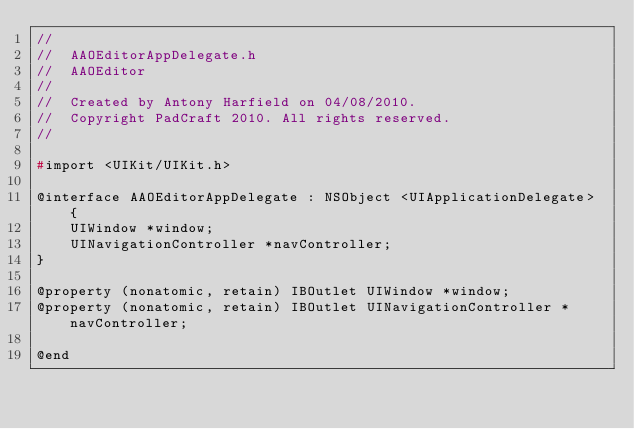Convert code to text. <code><loc_0><loc_0><loc_500><loc_500><_C_>//
//  AAOEditorAppDelegate.h
//  AAOEditor
//
//  Created by Antony Harfield on 04/08/2010.
//  Copyright PadCraft 2010. All rights reserved.
//

#import <UIKit/UIKit.h>

@interface AAOEditorAppDelegate : NSObject <UIApplicationDelegate> {
    UIWindow *window;
	UINavigationController *navController;
}

@property (nonatomic, retain) IBOutlet UIWindow *window;
@property (nonatomic, retain) IBOutlet UINavigationController *navController;

@end

</code> 